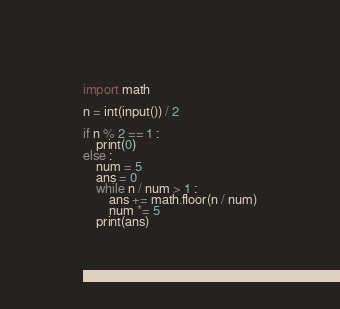<code> <loc_0><loc_0><loc_500><loc_500><_Python_>import math

n = int(input()) / 2

if n % 2 == 1 :
    print(0)
else :
    num = 5
    ans = 0
    while n / num > 1 :
        ans += math.floor(n / num)
        num *= 5
    print(ans)</code> 